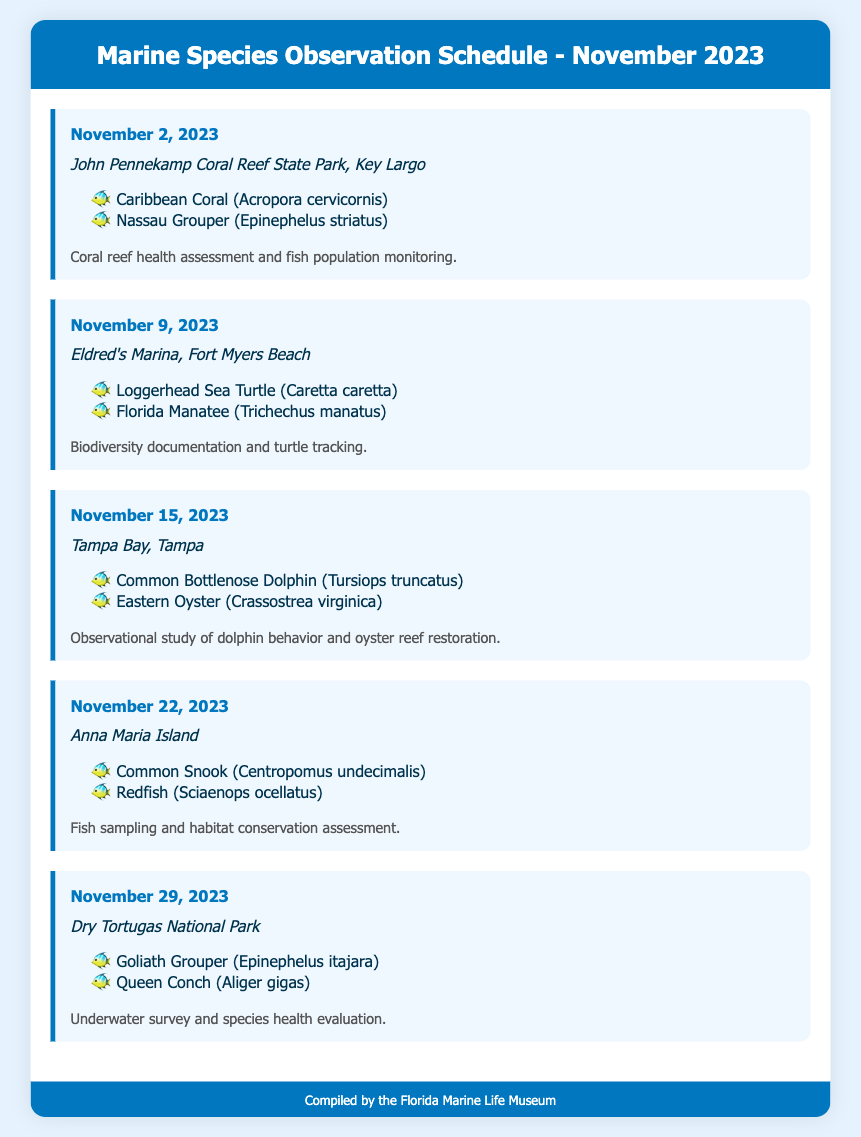What is the first observation date in November? The first observation date listed in the document is November 2, 2023.
Answer: November 2, 2023 Where is the observation on November 9, 2023? The observation on November 9, 2023, takes place at Eldred's Marina, Fort Myers Beach.
Answer: Eldred's Marina, Fort Myers Beach Which species are targeted for observation on November 15, 2023? The species targeted for observation on November 15, 2023, include the Common Bottlenose Dolphin and the Eastern Oyster.
Answer: Common Bottlenose Dolphin; Eastern Oyster How many observation dates are listed in the document? The document lists five observation dates for the month of November.
Answer: Five What type of activity is scheduled for November 22, 2023? The activity scheduled for November 22, 2023, includes fish sampling and habitat conservation assessment.
Answer: Fish sampling and habitat conservation assessment What location is associated with the Goliath Grouper observation? The Goliath Grouper observation is associated with Dry Tortugas National Park.
Answer: Dry Tortugas National Park What is the primary focus of the observation on November 2, 2023? The primary focus of the observation on November 2, 2023, is coral reef health assessment and fish population monitoring.
Answer: Coral reef health assessment and fish population monitoring Which species will be documented at Anna Maria Island? The species to be documented at Anna Maria Island are the Common Snook and Redfish.
Answer: Common Snook; Redfish 